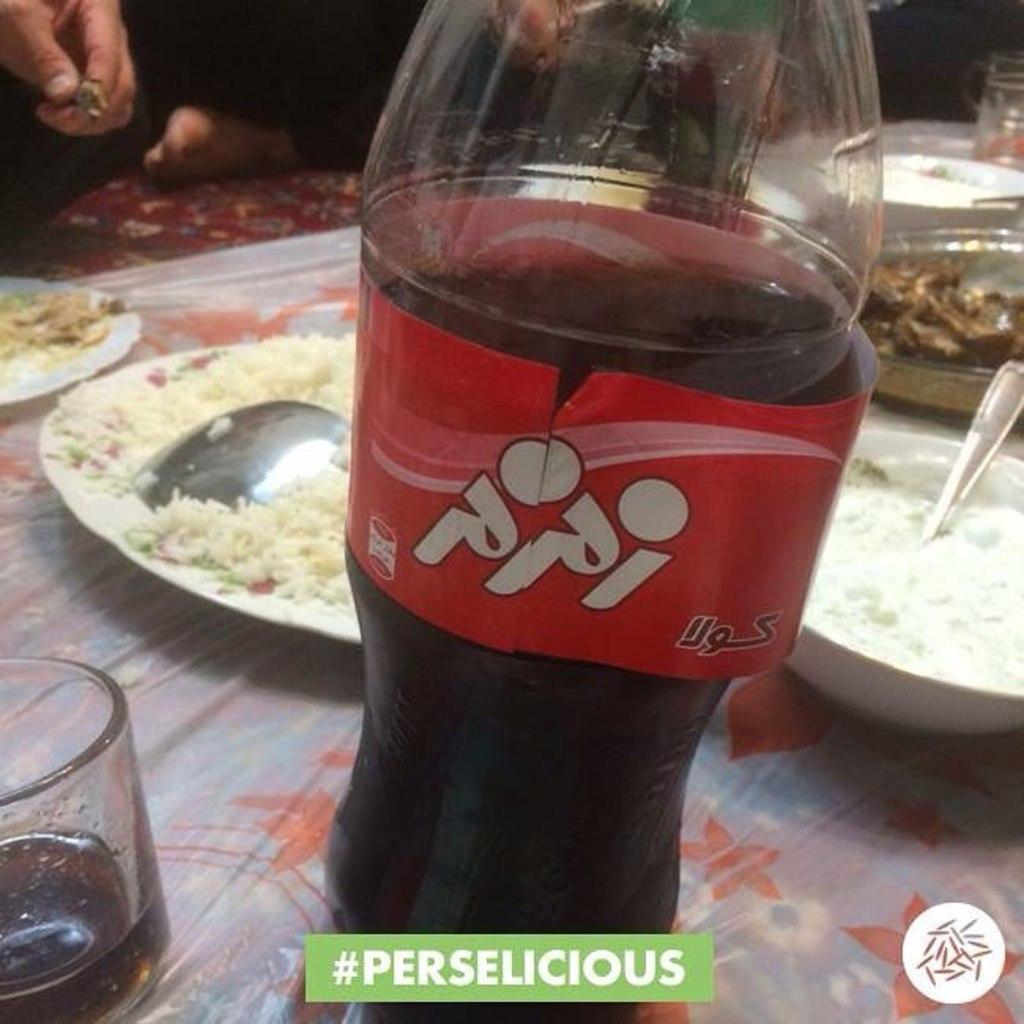What type of container is present in the image? There is a bottle in the image. What other type of container is present in the image? There is a glass in the image. What other items can be seen in the image related to serving or eating food? There are plates, a spoon, and bowls in the image. What is present in the image that indicates food is being served or eaten? There is food in the image. Is there a person present in the image? Yes, there is a human in the image. How many geese are present in the image? There are no geese present in the image. What type of system is being used to serve the food in the image? There is no specific system mentioned or depicted in the image for serving the food. 